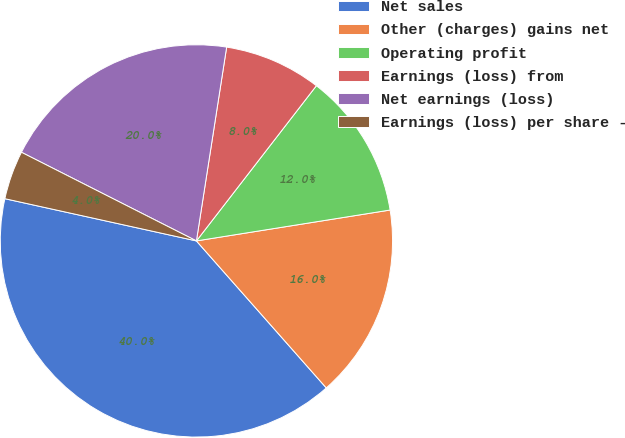<chart> <loc_0><loc_0><loc_500><loc_500><pie_chart><fcel>Net sales<fcel>Other (charges) gains net<fcel>Operating profit<fcel>Earnings (loss) from<fcel>Net earnings (loss)<fcel>Earnings (loss) per share -<nl><fcel>39.97%<fcel>16.0%<fcel>12.01%<fcel>8.01%<fcel>20.0%<fcel>4.01%<nl></chart> 